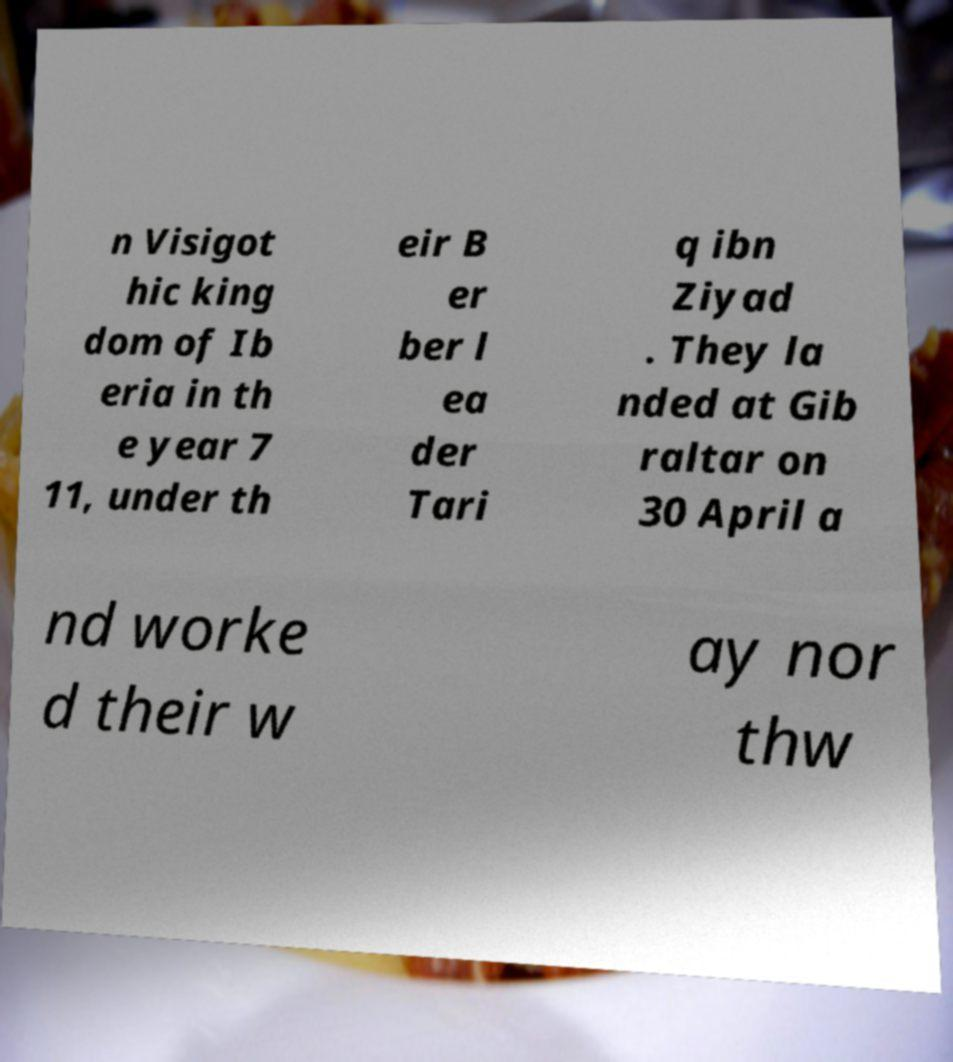There's text embedded in this image that I need extracted. Can you transcribe it verbatim? n Visigot hic king dom of Ib eria in th e year 7 11, under th eir B er ber l ea der Tari q ibn Ziyad . They la nded at Gib raltar on 30 April a nd worke d their w ay nor thw 